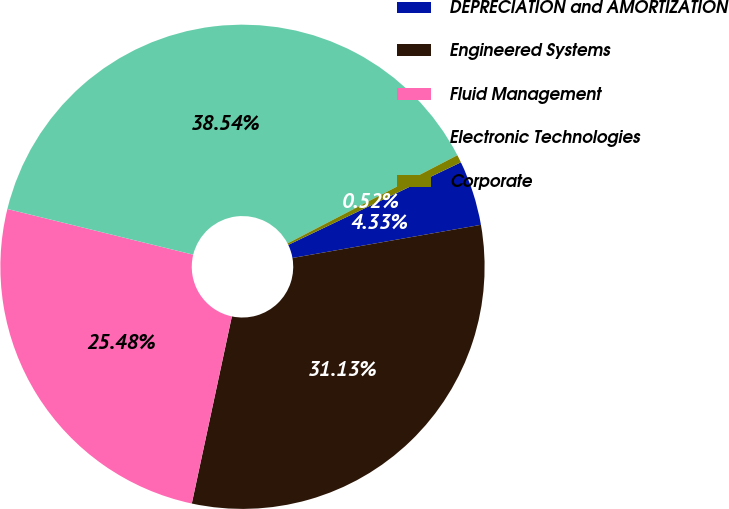Convert chart. <chart><loc_0><loc_0><loc_500><loc_500><pie_chart><fcel>DEPRECIATION and AMORTIZATION<fcel>Engineered Systems<fcel>Fluid Management<fcel>Electronic Technologies<fcel>Corporate<nl><fcel>4.33%<fcel>31.13%<fcel>25.48%<fcel>38.54%<fcel>0.52%<nl></chart> 